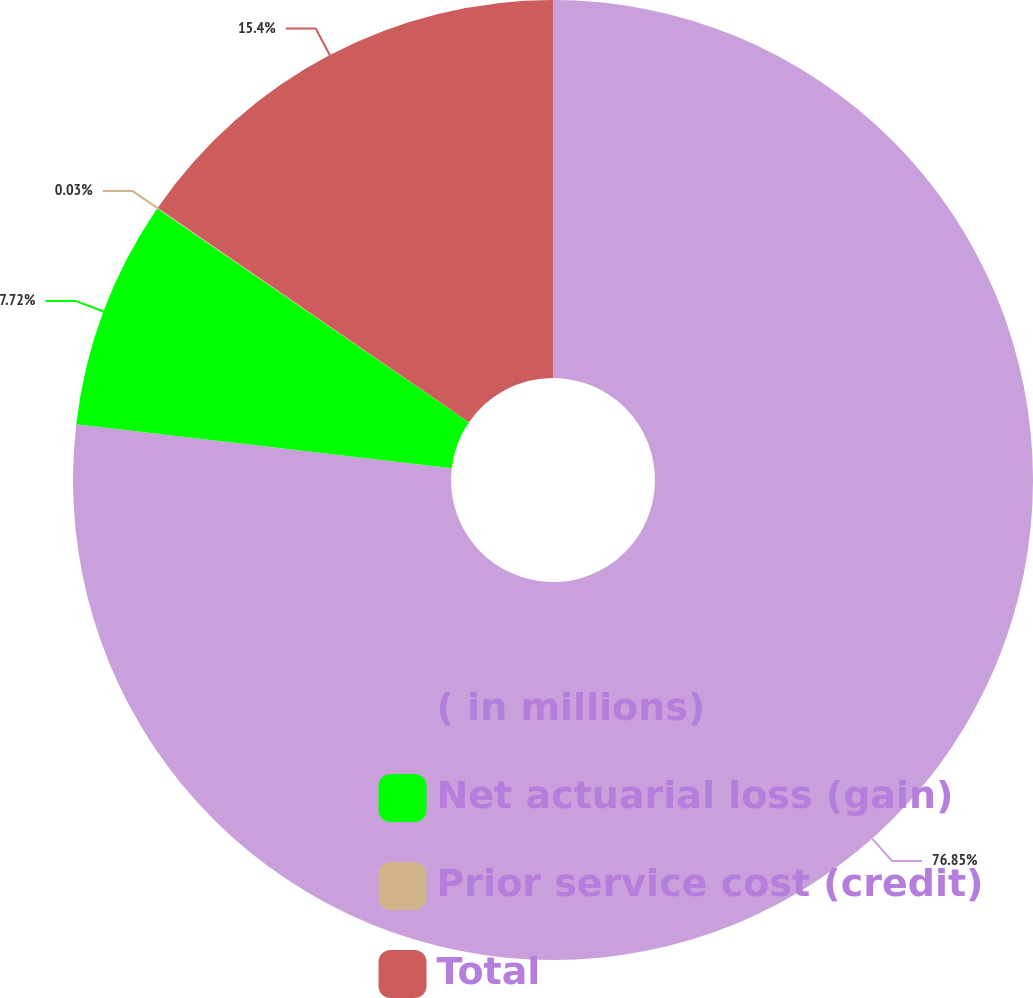<chart> <loc_0><loc_0><loc_500><loc_500><pie_chart><fcel>( in millions)<fcel>Net actuarial loss (gain)<fcel>Prior service cost (credit)<fcel>Total<nl><fcel>76.85%<fcel>7.72%<fcel>0.03%<fcel>15.4%<nl></chart> 